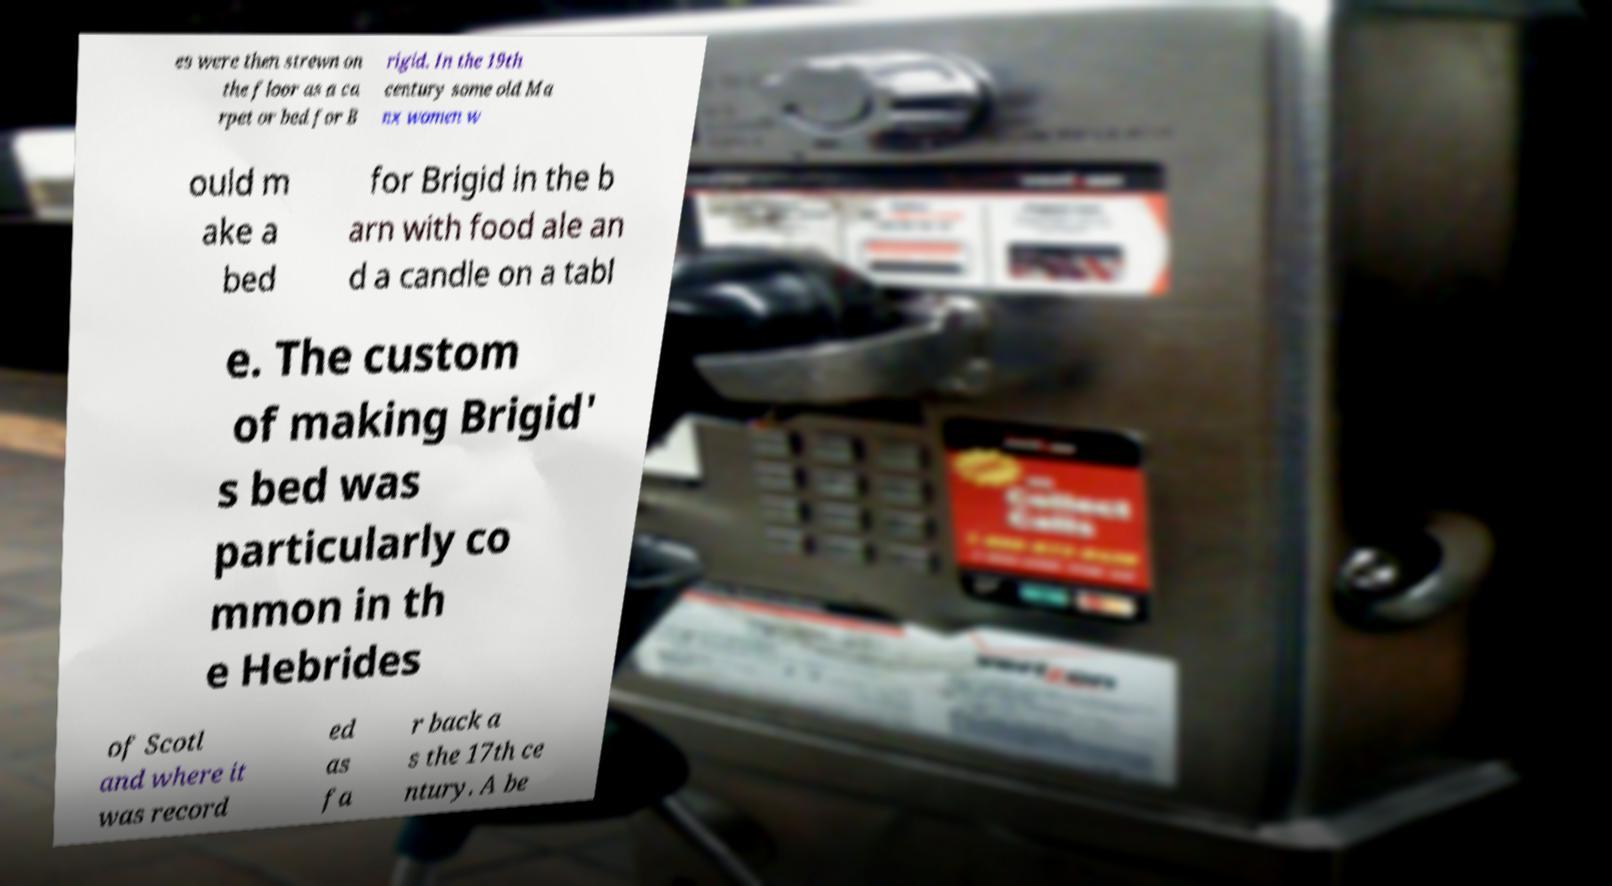For documentation purposes, I need the text within this image transcribed. Could you provide that? es were then strewn on the floor as a ca rpet or bed for B rigid. In the 19th century some old Ma nx women w ould m ake a bed for Brigid in the b arn with food ale an d a candle on a tabl e. The custom of making Brigid' s bed was particularly co mmon in th e Hebrides of Scotl and where it was record ed as fa r back a s the 17th ce ntury. A be 